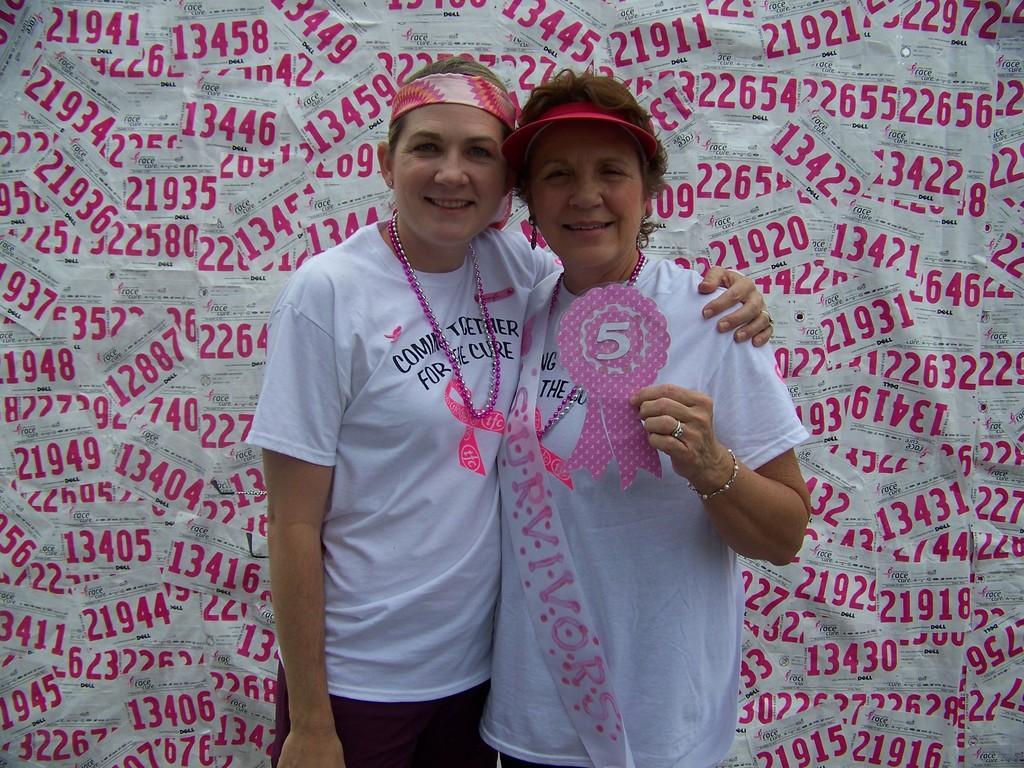In one or two sentences, can you explain what this image depicts? In this picture we can see two women standing here, they wore white color t-shirts, we can see some papers in the background, we can see a tag here. 